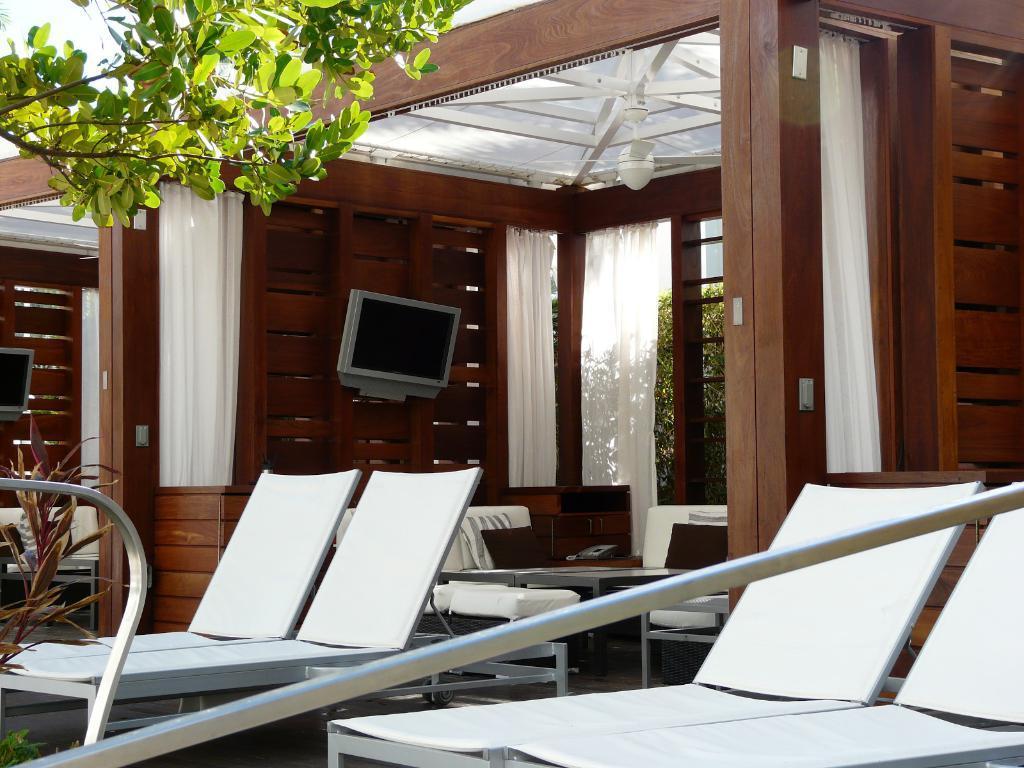Can you describe this image briefly? These are the rooms. I can see a television attached to the wooden board. These are the curtains hanging to the hangers. I can see the chairs. This looks like a couch. I think this is the table. I can see the trees and a plant. 